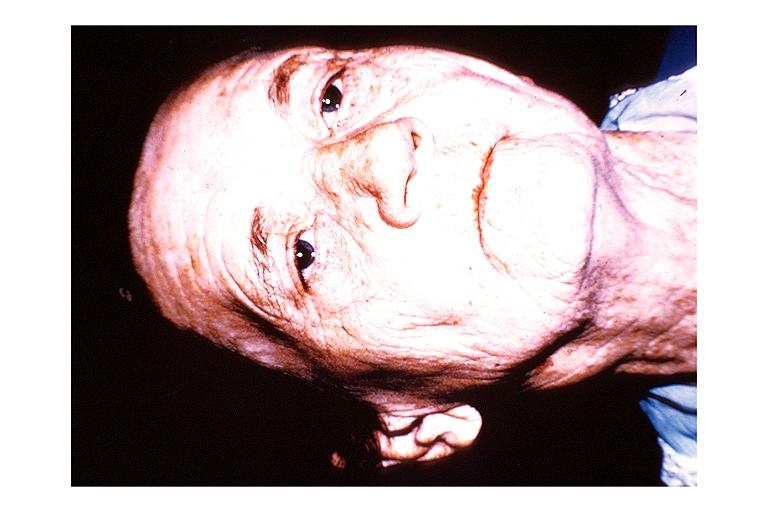what does this image show?
Answer the question using a single word or phrase. Papillary cystadenoma lymphomatosum warthins 